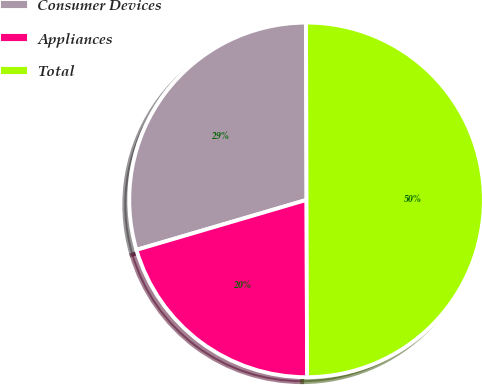Convert chart. <chart><loc_0><loc_0><loc_500><loc_500><pie_chart><fcel>Consumer Devices<fcel>Appliances<fcel>Total<nl><fcel>29.5%<fcel>20.5%<fcel>50.0%<nl></chart> 